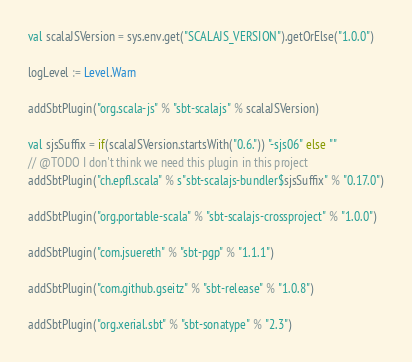Convert code to text. <code><loc_0><loc_0><loc_500><loc_500><_Scala_>val scalaJSVersion = sys.env.get("SCALAJS_VERSION").getOrElse("1.0.0")

logLevel := Level.Warn

addSbtPlugin("org.scala-js" % "sbt-scalajs" % scalaJSVersion)

val sjsSuffix = if(scalaJSVersion.startsWith("0.6.")) "-sjs06" else ""
// @TODO I don't think we need this plugin in this project
addSbtPlugin("ch.epfl.scala" % s"sbt-scalajs-bundler$sjsSuffix" % "0.17.0")

addSbtPlugin("org.portable-scala" % "sbt-scalajs-crossproject" % "1.0.0")

addSbtPlugin("com.jsuereth" % "sbt-pgp" % "1.1.1")

addSbtPlugin("com.github.gseitz" % "sbt-release" % "1.0.8")

addSbtPlugin("org.xerial.sbt" % "sbt-sonatype" % "2.3")
</code> 